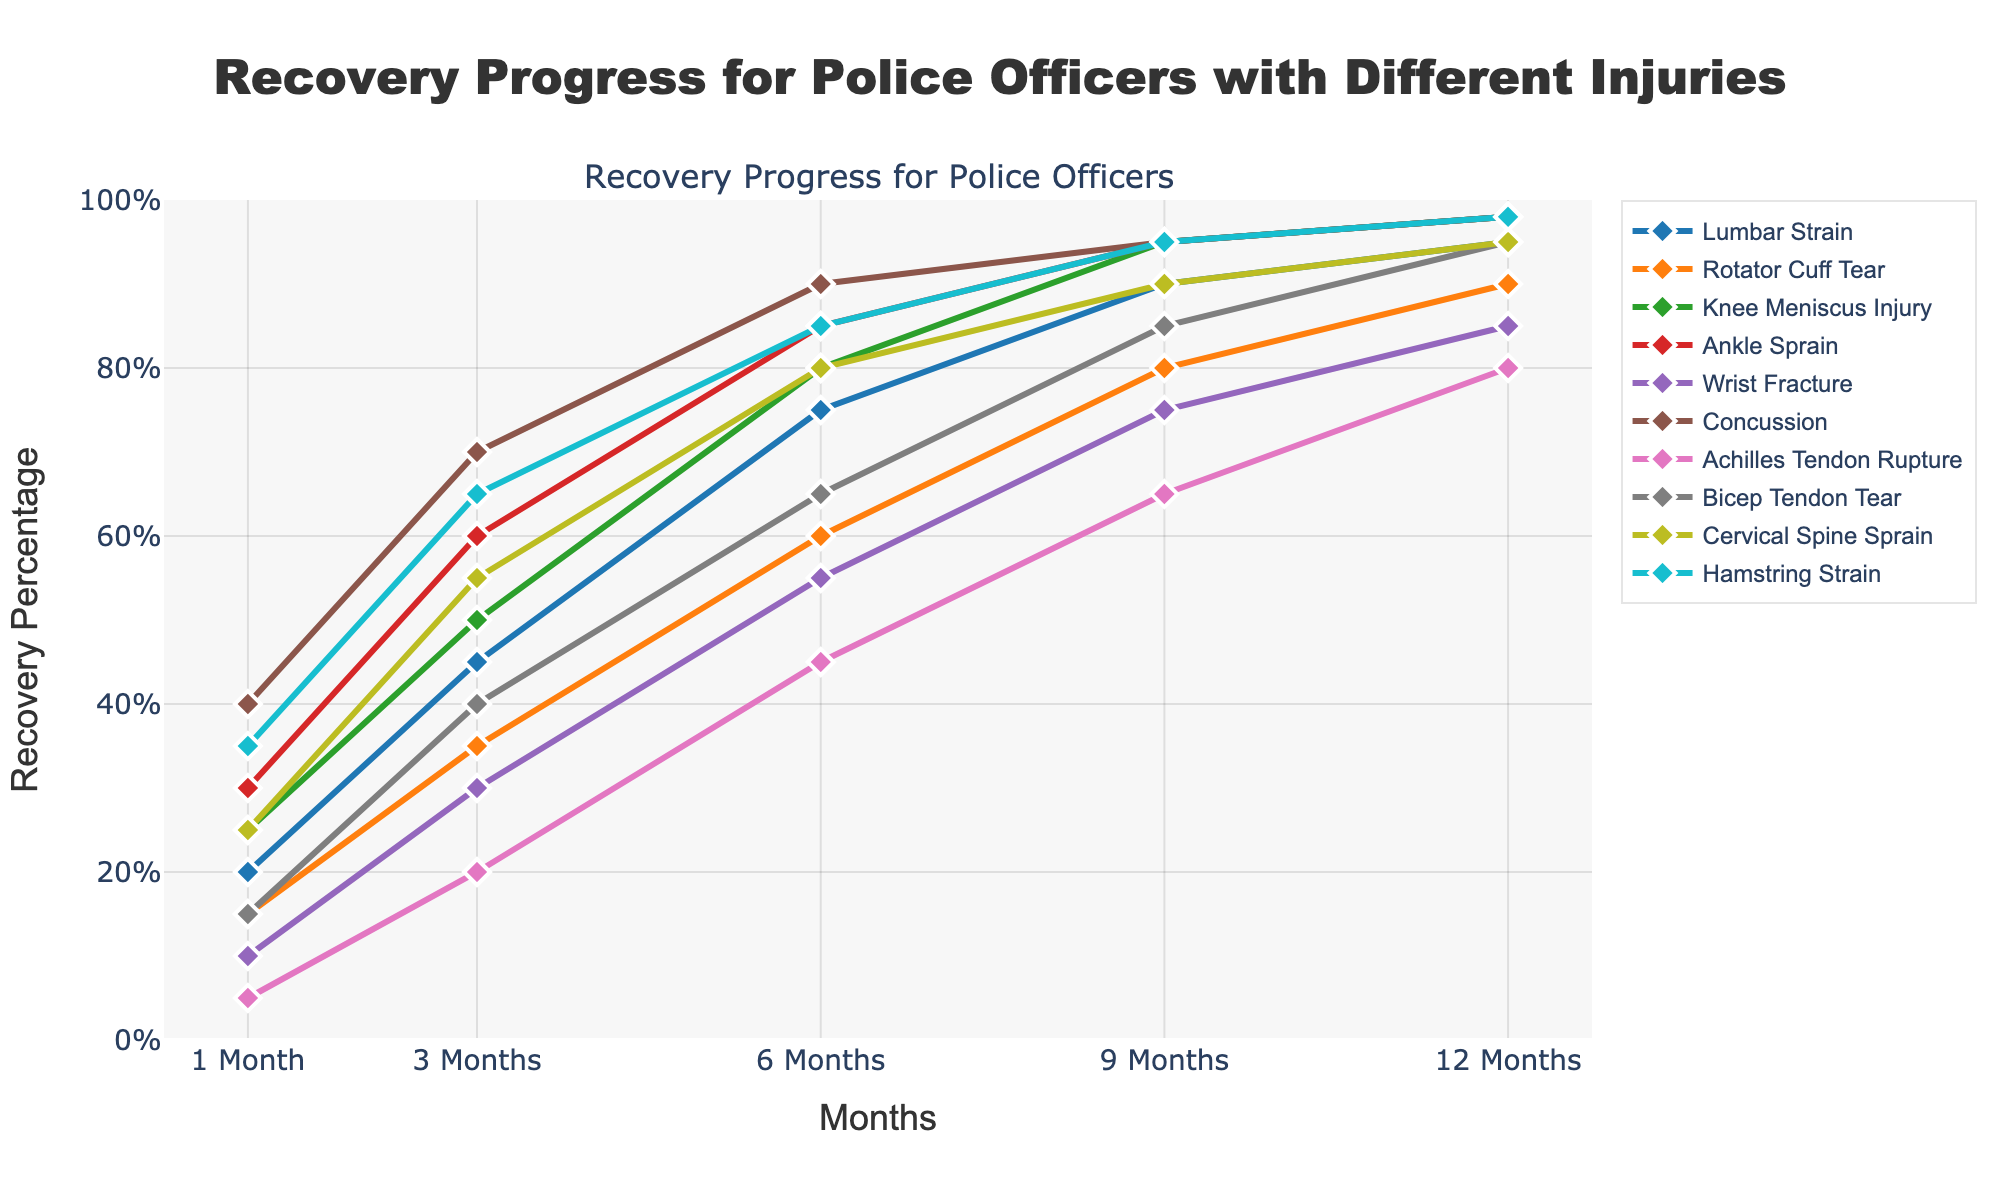What's the injury type with the highest recovery percentage at 1 month? By examining the line chart, look at the point corresponding to 1 month for each injury type. The highest recovery percentage is seen at the point with the highest vertical position.
Answer: Concussion Which injury type reaches a 90% recovery percentage first? By examining the line chart, look for the first injury type that reaches or exceeds the 90% recovery line.
Answer: Concussion Which injury type has the slowest initial recovery within the first 3 months? Examine the recovery percentages at the 3-month mark and identify which injury type has the lowest value.
Answer: Achilles Tendon Rupture Compare the recovery percentages of Lumbar Strain and Bicep Tendon Tear at 12 months; which is higher and by how much? Identify the recovery percentages of Lumbar Strain and Bicep Tendon Tear at 12 months, then subtract the lower value from the higher value. The values are:
- Lumbar Strain: 95%
- Bicep Tendon Tear: 95%
Both are the same, so the difference is 0%.
Answer: Both are the same, 0% 